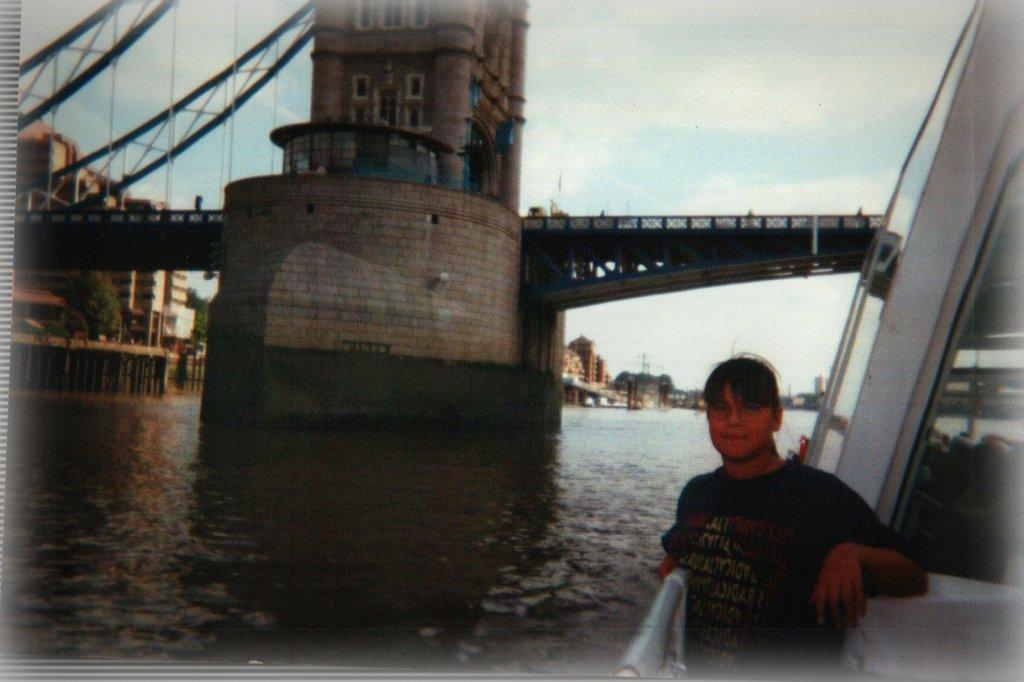In one or two sentences, can you explain what this image depicts? This picture is clicked outside the city. On the right we can see a person wearing t-shirt and standing. On the left we can see a water body, we can see the bridges, tower, metal rods and some other items. In the background we can see the sky, trees and buildings. 